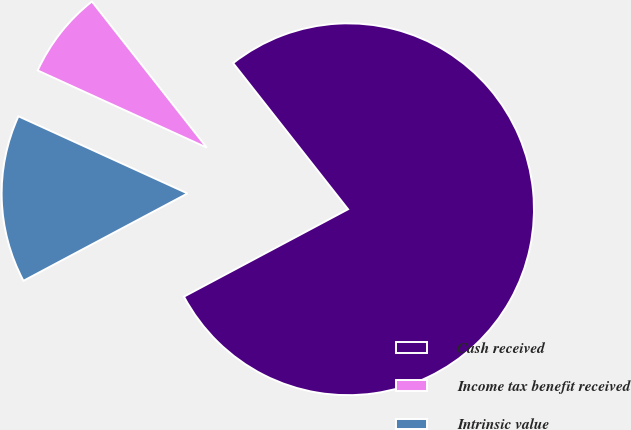<chart> <loc_0><loc_0><loc_500><loc_500><pie_chart><fcel>Cash received<fcel>Income tax benefit received<fcel>Intrinsic value<nl><fcel>77.82%<fcel>7.58%<fcel>14.6%<nl></chart> 